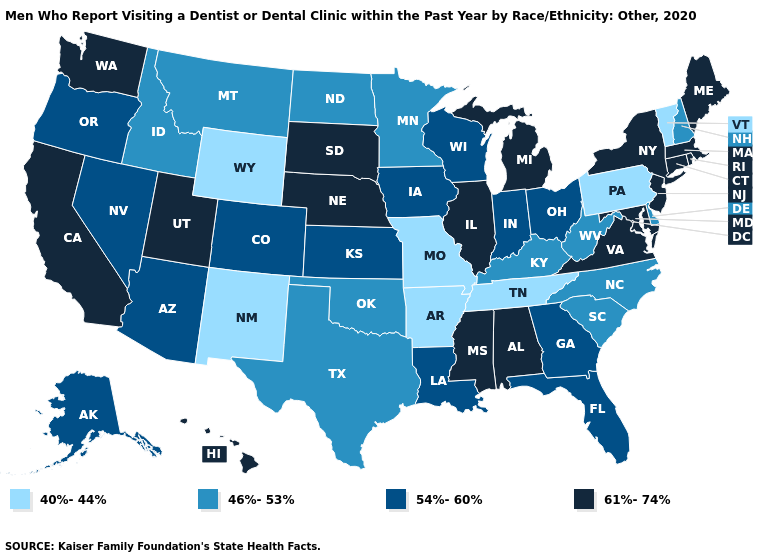What is the lowest value in states that border Massachusetts?
Concise answer only. 40%-44%. Name the states that have a value in the range 61%-74%?
Give a very brief answer. Alabama, California, Connecticut, Hawaii, Illinois, Maine, Maryland, Massachusetts, Michigan, Mississippi, Nebraska, New Jersey, New York, Rhode Island, South Dakota, Utah, Virginia, Washington. Does Indiana have the highest value in the MidWest?
Answer briefly. No. What is the value of Montana?
Keep it brief. 46%-53%. What is the value of Oregon?
Concise answer only. 54%-60%. What is the highest value in states that border Nevada?
Be succinct. 61%-74%. Which states have the highest value in the USA?
Keep it brief. Alabama, California, Connecticut, Hawaii, Illinois, Maine, Maryland, Massachusetts, Michigan, Mississippi, Nebraska, New Jersey, New York, Rhode Island, South Dakota, Utah, Virginia, Washington. Which states have the highest value in the USA?
Keep it brief. Alabama, California, Connecticut, Hawaii, Illinois, Maine, Maryland, Massachusetts, Michigan, Mississippi, Nebraska, New Jersey, New York, Rhode Island, South Dakota, Utah, Virginia, Washington. Name the states that have a value in the range 46%-53%?
Answer briefly. Delaware, Idaho, Kentucky, Minnesota, Montana, New Hampshire, North Carolina, North Dakota, Oklahoma, South Carolina, Texas, West Virginia. Does Mississippi have a higher value than Vermont?
Give a very brief answer. Yes. What is the value of Nebraska?
Keep it brief. 61%-74%. What is the lowest value in the USA?
Quick response, please. 40%-44%. Does Missouri have the lowest value in the MidWest?
Answer briefly. Yes. What is the value of Nebraska?
Short answer required. 61%-74%. 